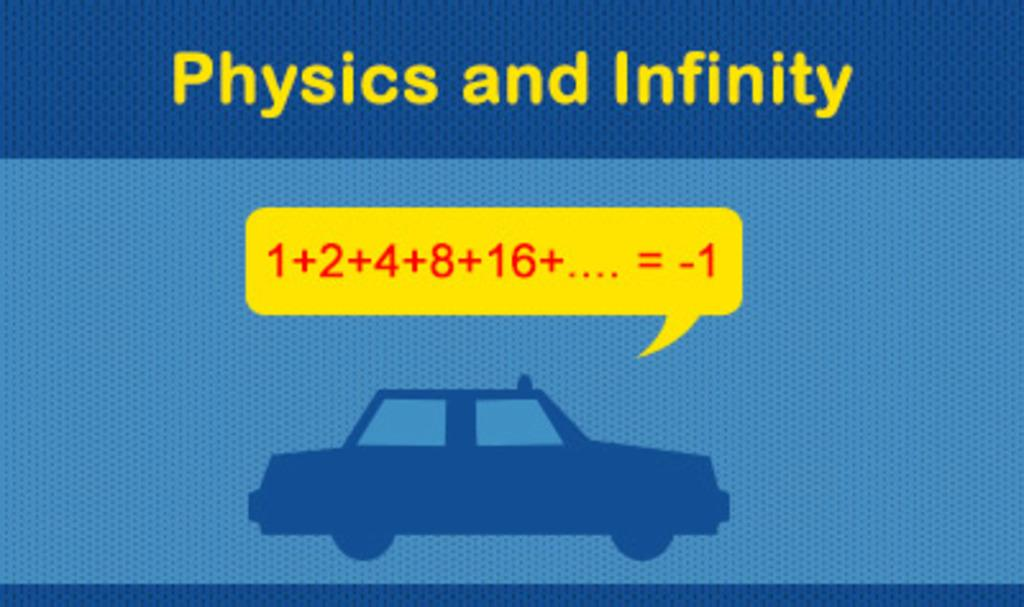What is the main subject of the picture? The main subject of the picture is an image of a car design. What other elements are present in the picture besides the car design? There are alphabets and numbers written in the picture. What color is the surface in the backdrop of the picture? The surface in the backdrop of the picture is blue. How does the car design affect the mind of the person viewing the image? The image does not provide information about the person viewing it or their mental state, so we cannot determine how the car design affects their mind. 